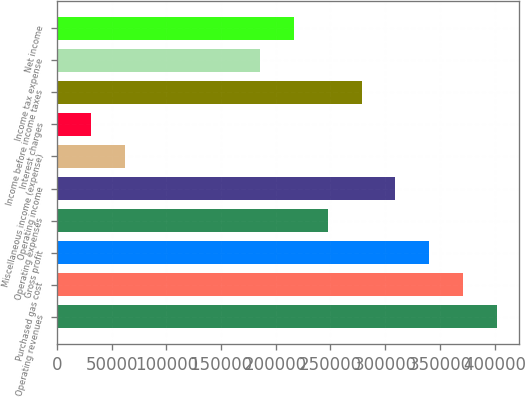<chart> <loc_0><loc_0><loc_500><loc_500><bar_chart><fcel>Operating revenues<fcel>Purchased gas cost<fcel>Gross profit<fcel>Operating expenses<fcel>Operating income<fcel>Miscellaneous income (expense)<fcel>Interest charges<fcel>Income before income taxes<fcel>Income tax expense<fcel>Net income<nl><fcel>402216<fcel>371276<fcel>340337<fcel>247518<fcel>309397<fcel>61880.2<fcel>30940.7<fcel>278457<fcel>185639<fcel>216578<nl></chart> 